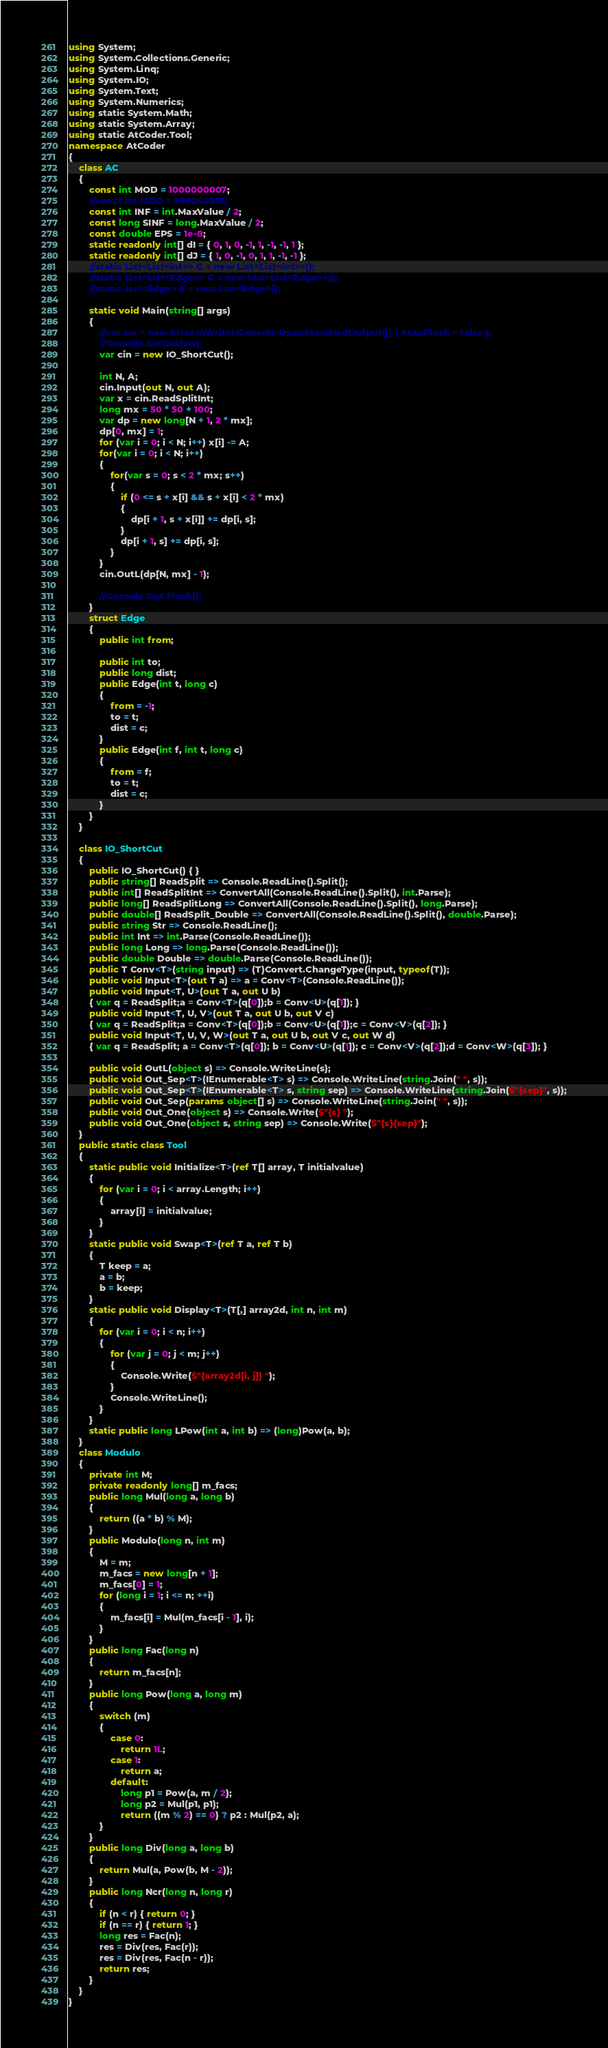Convert code to text. <code><loc_0><loc_0><loc_500><loc_500><_C#_>using System;
using System.Collections.Generic;
using System.Linq;
using System.IO;
using System.Text;
using System.Numerics;
using static System.Math;
using static System.Array;
using static AtCoder.Tool;
namespace AtCoder
{
    class AC
    {
        const int MOD = 1000000007;
        //const int MOD = 998244353;
        const int INF = int.MaxValue / 2;
        const long SINF = long.MaxValue / 2;
        const double EPS = 1e-8;
        static readonly int[] dI = { 0, 1, 0, -1, 1, -1, -1, 1 };
        static readonly int[] dJ = { 1, 0, -1, 0, 1, 1, -1, -1 };
        //static List<List<int>> G = new List<List<int>>();
        //static List<List<Edge>> G = new List<List<Edge>>();
        //static List<Edge> E = new List<Edge>();

        static void Main(string[] args)
        {
            //var sw = new StreamWriter(Console.OpenStandardOutput()) { AutoFlush = false };
            //Console.SetOut(sw);
            var cin = new IO_ShortCut();

            int N, A;
            cin.Input(out N, out A);
            var x = cin.ReadSplitInt;
            long mx = 50 * 50 + 100;
            var dp = new long[N + 1, 2 * mx];
            dp[0, mx] = 1;
            for (var i = 0; i < N; i++) x[i] -= A;
            for(var i = 0; i < N; i++)
            {
                for(var s = 0; s < 2 * mx; s++)
                {
                    if (0 <= s + x[i] && s + x[i] < 2 * mx)
                    {
                        dp[i + 1, s + x[i]] += dp[i, s];
                    }
                    dp[i + 1, s] += dp[i, s];
                }
            }
            cin.OutL(dp[N, mx] - 1);

            //Console.Out.Flush();
        }
        struct Edge
        {
            public int from;

            public int to;
            public long dist;
            public Edge(int t, long c)
            {
                from = -1;
                to = t;
                dist = c;
            }
            public Edge(int f, int t, long c)
            {
                from = f;
                to = t;
                dist = c;
            }
        }
    }
    
    class IO_ShortCut
    {
        public IO_ShortCut() { }
        public string[] ReadSplit => Console.ReadLine().Split();
        public int[] ReadSplitInt => ConvertAll(Console.ReadLine().Split(), int.Parse);
        public long[] ReadSplitLong => ConvertAll(Console.ReadLine().Split(), long.Parse);
        public double[] ReadSplit_Double => ConvertAll(Console.ReadLine().Split(), double.Parse);
        public string Str => Console.ReadLine();
        public int Int => int.Parse(Console.ReadLine());
        public long Long => long.Parse(Console.ReadLine());
        public double Double => double.Parse(Console.ReadLine());
        public T Conv<T>(string input) => (T)Convert.ChangeType(input, typeof(T));
        public void Input<T>(out T a) => a = Conv<T>(Console.ReadLine());
        public void Input<T, U>(out T a, out U b)
        { var q = ReadSplit;a = Conv<T>(q[0]);b = Conv<U>(q[1]); }
        public void Input<T, U, V>(out T a, out U b, out V c)
        { var q = ReadSplit;a = Conv<T>(q[0]);b = Conv<U>(q[1]);c = Conv<V>(q[2]); }
        public void Input<T, U, V, W>(out T a, out U b, out V c, out W d)
        { var q = ReadSplit; a = Conv<T>(q[0]); b = Conv<U>(q[1]); c = Conv<V>(q[2]);d = Conv<W>(q[3]); }

        public void OutL(object s) => Console.WriteLine(s);
        public void Out_Sep<T>(IEnumerable<T> s) => Console.WriteLine(string.Join(" ", s));
        public void Out_Sep<T>(IEnumerable<T> s, string sep) => Console.WriteLine(string.Join($"{sep}", s));
        public void Out_Sep(params object[] s) => Console.WriteLine(string.Join(" ", s));
        public void Out_One(object s) => Console.Write($"{s} ");
        public void Out_One(object s, string sep) => Console.Write($"{s}{sep}");
    }
    public static class Tool
    {
        static public void Initialize<T>(ref T[] array, T initialvalue)
        {
            for (var i = 0; i < array.Length; i++)
            {
                array[i] = initialvalue;
            }
        }
        static public void Swap<T>(ref T a, ref T b)
        {
            T keep = a;
            a = b;
            b = keep;
        }
        static public void Display<T>(T[,] array2d, int n, int m)
        {
            for (var i = 0; i < n; i++)
            {
                for (var j = 0; j < m; j++)
                {
                    Console.Write($"{array2d[i, j]} ");
                }
                Console.WriteLine();
            }
        }
        static public long LPow(int a, int b) => (long)Pow(a, b);
    }
    class Modulo
    {
        private int M;
        private readonly long[] m_facs;
        public long Mul(long a, long b)
        {
            return ((a * b) % M);
        }
        public Modulo(long n, int m)
        {
            M = m;
            m_facs = new long[n + 1];
            m_facs[0] = 1;
            for (long i = 1; i <= n; ++i)
            {
                m_facs[i] = Mul(m_facs[i - 1], i);
            }
        }
        public long Fac(long n)
        {
            return m_facs[n];
        }
        public long Pow(long a, long m)
        {
            switch (m)
            {
                case 0:
                    return 1L;
                case 1:
                    return a;
                default:
                    long p1 = Pow(a, m / 2);
                    long p2 = Mul(p1, p1);
                    return ((m % 2) == 0) ? p2 : Mul(p2, a);
            }
        }
        public long Div(long a, long b)
        {
            return Mul(a, Pow(b, M - 2));
        }
        public long Ncr(long n, long r)
        {
            if (n < r) { return 0; }
            if (n == r) { return 1; }
            long res = Fac(n);
            res = Div(res, Fac(r));
            res = Div(res, Fac(n - r));
            return res;
        }
    }
}
</code> 